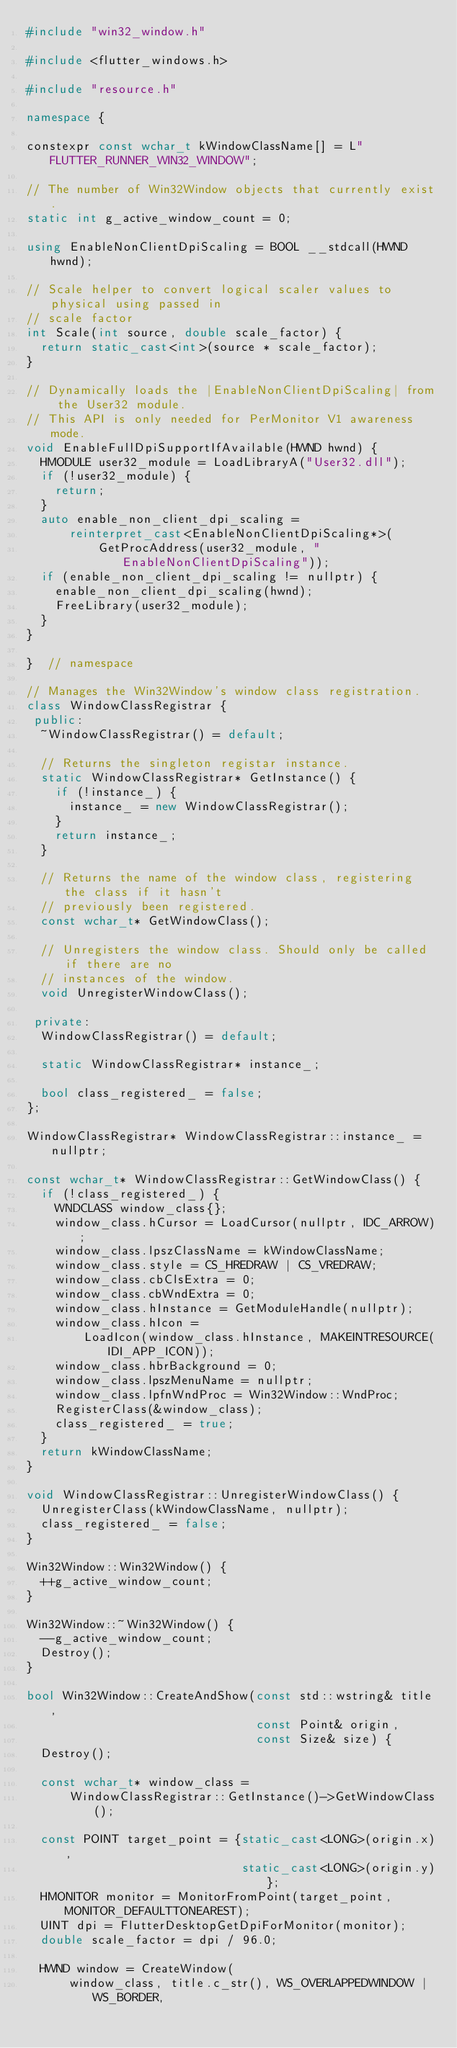<code> <loc_0><loc_0><loc_500><loc_500><_C++_>#include "win32_window.h"

#include <flutter_windows.h>

#include "resource.h"

namespace {

constexpr const wchar_t kWindowClassName[] = L"FLUTTER_RUNNER_WIN32_WINDOW";

// The number of Win32Window objects that currently exist.
static int g_active_window_count = 0;

using EnableNonClientDpiScaling = BOOL __stdcall(HWND hwnd);

// Scale helper to convert logical scaler values to physical using passed in
// scale factor
int Scale(int source, double scale_factor) {
  return static_cast<int>(source * scale_factor);
}

// Dynamically loads the |EnableNonClientDpiScaling| from the User32 module.
// This API is only needed for PerMonitor V1 awareness mode.
void EnableFullDpiSupportIfAvailable(HWND hwnd) {
  HMODULE user32_module = LoadLibraryA("User32.dll");
  if (!user32_module) {
    return;
  }
  auto enable_non_client_dpi_scaling =
      reinterpret_cast<EnableNonClientDpiScaling*>(
          GetProcAddress(user32_module, "EnableNonClientDpiScaling"));
  if (enable_non_client_dpi_scaling != nullptr) {
    enable_non_client_dpi_scaling(hwnd);
    FreeLibrary(user32_module);
  }
}

}  // namespace

// Manages the Win32Window's window class registration.
class WindowClassRegistrar {
 public:
  ~WindowClassRegistrar() = default;

  // Returns the singleton registar instance.
  static WindowClassRegistrar* GetInstance() {
    if (!instance_) {
      instance_ = new WindowClassRegistrar();
    }
    return instance_;
  }

  // Returns the name of the window class, registering the class if it hasn't
  // previously been registered.
  const wchar_t* GetWindowClass();

  // Unregisters the window class. Should only be called if there are no
  // instances of the window.
  void UnregisterWindowClass();

 private:
  WindowClassRegistrar() = default;

  static WindowClassRegistrar* instance_;

  bool class_registered_ = false;
};

WindowClassRegistrar* WindowClassRegistrar::instance_ = nullptr;

const wchar_t* WindowClassRegistrar::GetWindowClass() {
  if (!class_registered_) {
    WNDCLASS window_class{};
    window_class.hCursor = LoadCursor(nullptr, IDC_ARROW);
    window_class.lpszClassName = kWindowClassName;
    window_class.style = CS_HREDRAW | CS_VREDRAW;
    window_class.cbClsExtra = 0;
    window_class.cbWndExtra = 0;
    window_class.hInstance = GetModuleHandle(nullptr);
    window_class.hIcon =
        LoadIcon(window_class.hInstance, MAKEINTRESOURCE(IDI_APP_ICON));
    window_class.hbrBackground = 0;
    window_class.lpszMenuName = nullptr;
    window_class.lpfnWndProc = Win32Window::WndProc;
    RegisterClass(&window_class);
    class_registered_ = true;
  }
  return kWindowClassName;
}

void WindowClassRegistrar::UnregisterWindowClass() {
  UnregisterClass(kWindowClassName, nullptr);
  class_registered_ = false;
}

Win32Window::Win32Window() {
  ++g_active_window_count;
}

Win32Window::~Win32Window() {
  --g_active_window_count;
  Destroy();
}

bool Win32Window::CreateAndShow(const std::wstring& title,
                                const Point& origin,
                                const Size& size) {
  Destroy();

  const wchar_t* window_class =
      WindowClassRegistrar::GetInstance()->GetWindowClass();

  const POINT target_point = {static_cast<LONG>(origin.x),
                              static_cast<LONG>(origin.y)};
  HMONITOR monitor = MonitorFromPoint(target_point, MONITOR_DEFAULTTONEAREST);
  UINT dpi = FlutterDesktopGetDpiForMonitor(monitor);
  double scale_factor = dpi / 96.0;

  HWND window = CreateWindow(
      window_class, title.c_str(), WS_OVERLAPPEDWINDOW | WS_BORDER,</code> 